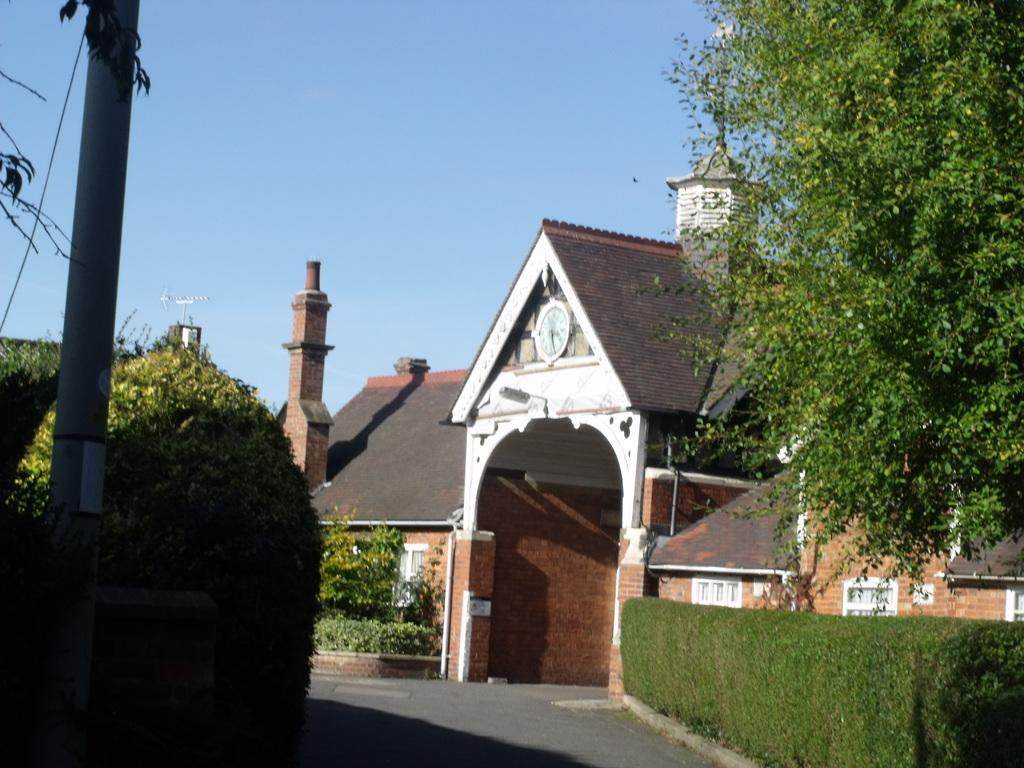What type of structure is visible in the image? There is a building in the image. What is located in front of the building? There are plants and trees in front of the building. Can you describe any other objects in the image? There is a pole and a path visible in the image. What can be seen in the background of the image? The sky is visible in the background of the image. What type of pin is being used for arithmetic in the image? There is no pin or arithmetic activity present in the image. What type of polish is being applied to the trees in the image? There is no polish or indication of any polishing activity in the image. 